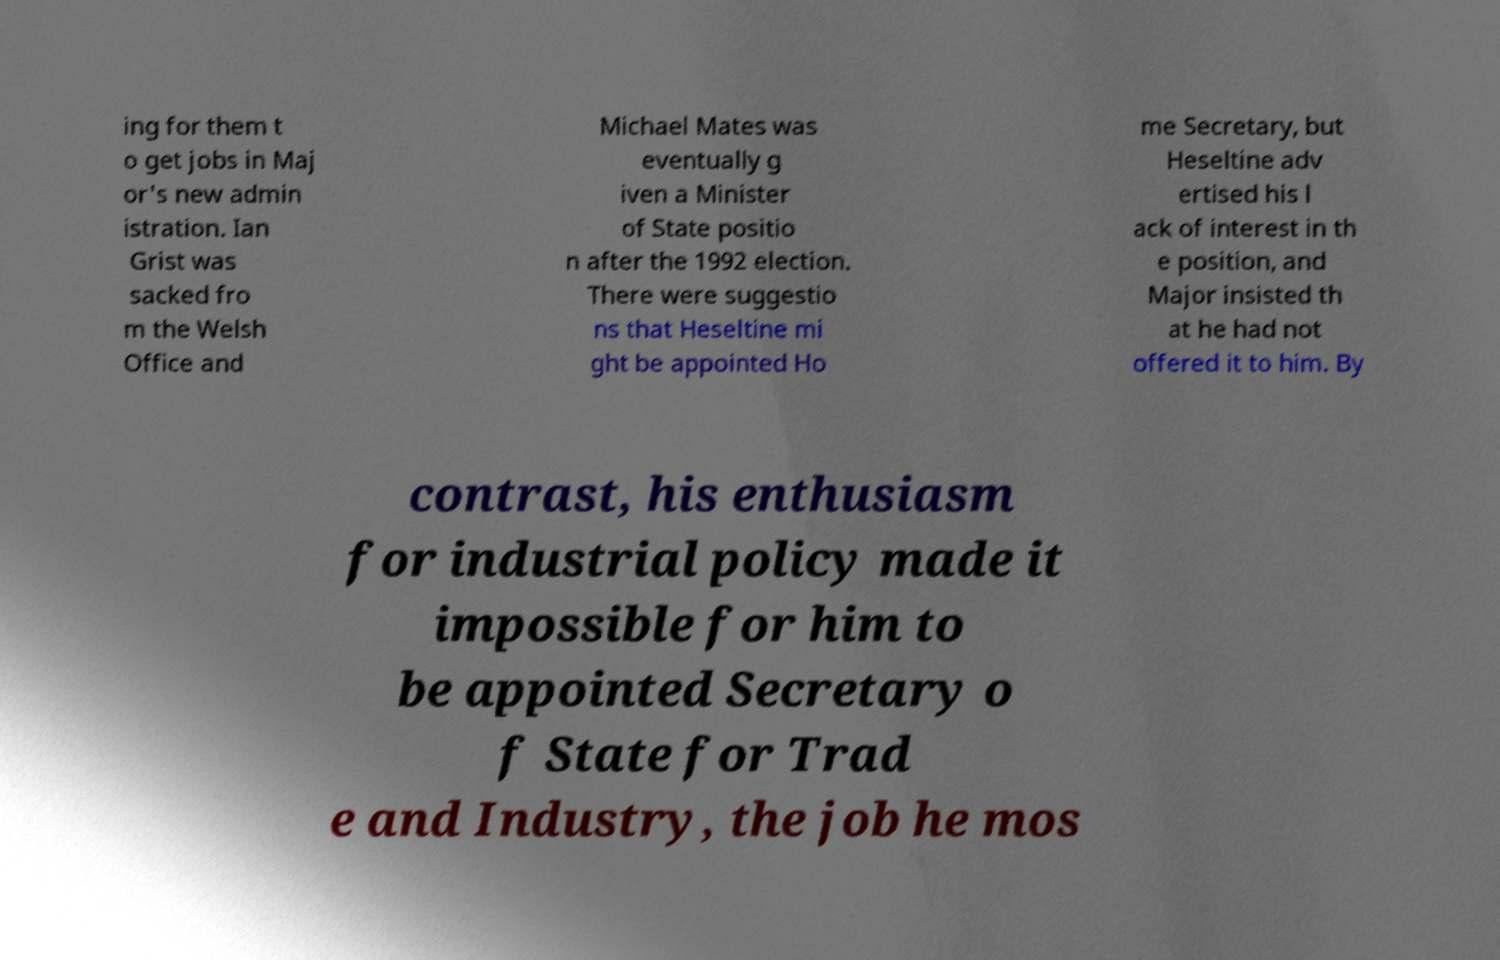What messages or text are displayed in this image? I need them in a readable, typed format. ing for them t o get jobs in Maj or's new admin istration. Ian Grist was sacked fro m the Welsh Office and Michael Mates was eventually g iven a Minister of State positio n after the 1992 election. There were suggestio ns that Heseltine mi ght be appointed Ho me Secretary, but Heseltine adv ertised his l ack of interest in th e position, and Major insisted th at he had not offered it to him. By contrast, his enthusiasm for industrial policy made it impossible for him to be appointed Secretary o f State for Trad e and Industry, the job he mos 